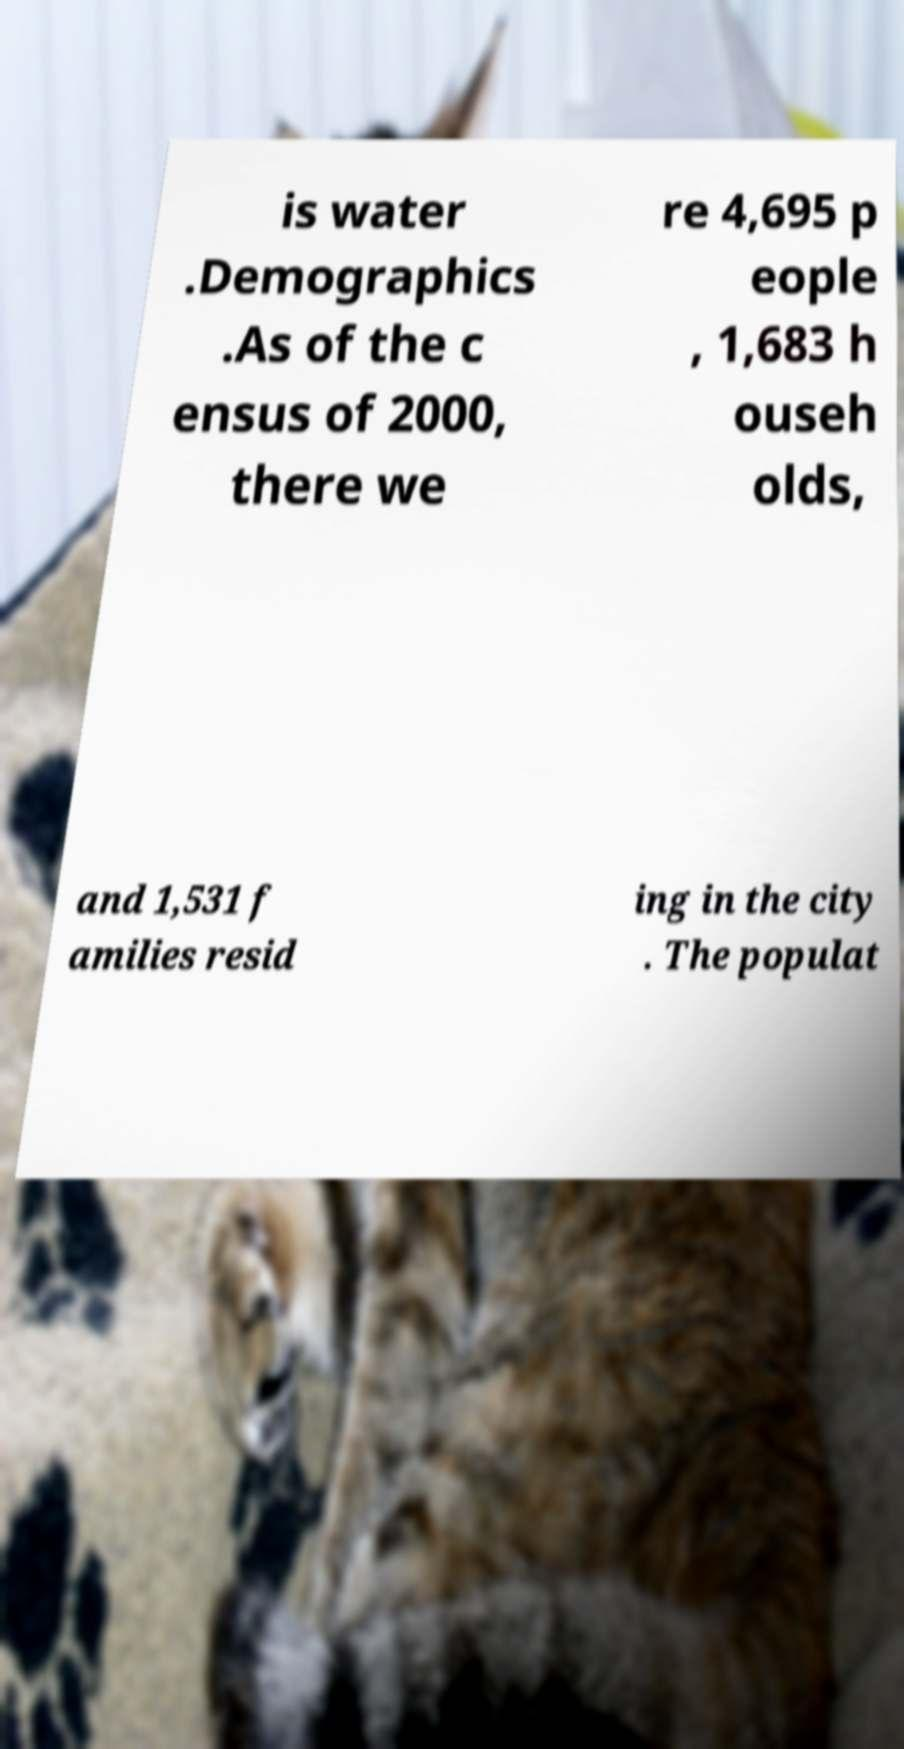I need the written content from this picture converted into text. Can you do that? is water .Demographics .As of the c ensus of 2000, there we re 4,695 p eople , 1,683 h ouseh olds, and 1,531 f amilies resid ing in the city . The populat 